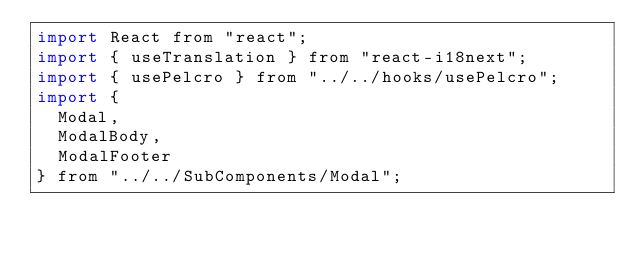Convert code to text. <code><loc_0><loc_0><loc_500><loc_500><_JavaScript_>import React from "react";
import { useTranslation } from "react-i18next";
import { usePelcro } from "../../hooks/usePelcro";
import {
  Modal,
  ModalBody,
  ModalFooter
} from "../../SubComponents/Modal";</code> 